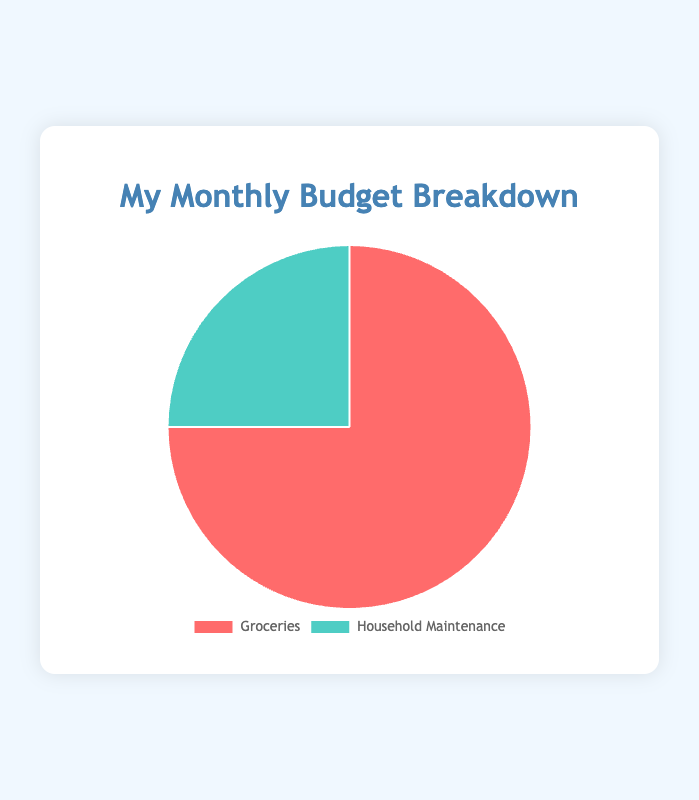What percentage of the budget is allocated to groceries? The total budget is the sum of groceries and household maintenance expenditures: 150 + 50 = 200. The percentage for groceries is (150 / 200) * 100 = 75%.
Answer: 75% What is the ratio of the budget spent on groceries to household maintenance? The ratio is calculated by dividing the amount spent on groceries by the amount spent on household maintenance: 150 / 50 = 3.
Answer: 3:1 Which category has the larger allocation, groceries or household maintenance? By looking at the pie chart, the section for groceries is larger than that for household maintenance. Therefore, groceries have a larger allocation.
Answer: Groceries How much more is spent on groceries compared to household maintenance? The difference between the expenditures on groceries and household maintenance is 150 - 50 = 100.
Answer: $100 If the total budget were to be reallocated so that the household maintenance portion is increased by 50%, what would the new budget allocation be for household maintenance? Increasing the household maintenance portion by 50% of $50 equals $50 * 0.50 = $25. The new budget for household maintenance would be $50 + $25 = $75.
Answer: $75 If the household maintenance budget was reduced by $10, what percentage of the new total budget would groceries represent? New household maintenance budget = $50 - $10 = $40, new total budget = $150 + $40 = $190, percentage for groceries = (150 / 190) * 100 ≈ 78.95%.
Answer: 78.95% What colors are used to represent the groceries and household maintenance categories? The section for groceries is represented in red, and the section for household maintenance is represented in green.
Answer: Red (groceries), Green (household maintenance) How does the allocation for household maintenance compare proportionally to groceries? Groceries account for more of the total budget than household maintenance. The proportion for groceries is 150/200 = 75%, while household maintenance is 50/200 = 25%.
Answer: Household maintenance is smaller What visual attribute stands out the most in the pie chart? The larger red section representing groceries immediately captures attention due to its size, which visually dominates the chart compared to the green section for household maintenance.
Answer: Larger proportion of red section 